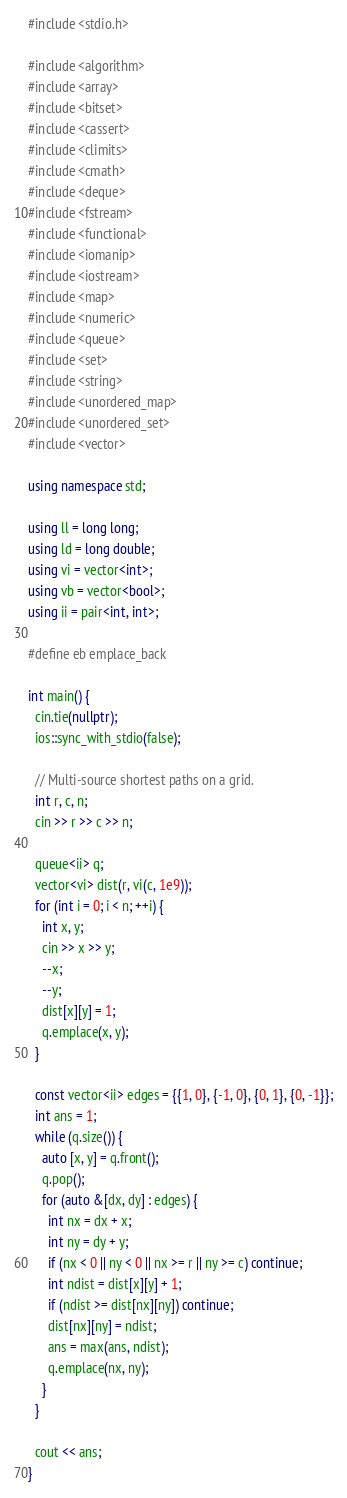<code> <loc_0><loc_0><loc_500><loc_500><_C++_>#include <stdio.h>

#include <algorithm>
#include <array>
#include <bitset>
#include <cassert>
#include <climits>
#include <cmath>
#include <deque>
#include <fstream>
#include <functional>
#include <iomanip>
#include <iostream>
#include <map>
#include <numeric>
#include <queue>
#include <set>
#include <string>
#include <unordered_map>
#include <unordered_set>
#include <vector>

using namespace std;

using ll = long long;
using ld = long double;
using vi = vector<int>;
using vb = vector<bool>;
using ii = pair<int, int>;

#define eb emplace_back

int main() {
  cin.tie(nullptr);
  ios::sync_with_stdio(false);

  // Multi-source shortest paths on a grid.
  int r, c, n;
  cin >> r >> c >> n;

  queue<ii> q;
  vector<vi> dist(r, vi(c, 1e9));
  for (int i = 0; i < n; ++i) {
    int x, y;
    cin >> x >> y;
    --x;
    --y;
    dist[x][y] = 1;
    q.emplace(x, y);
  }

  const vector<ii> edges = {{1, 0}, {-1, 0}, {0, 1}, {0, -1}};
  int ans = 1;
  while (q.size()) {
    auto [x, y] = q.front();
    q.pop();
    for (auto &[dx, dy] : edges) {
      int nx = dx + x;
      int ny = dy + y;
      if (nx < 0 || ny < 0 || nx >= r || ny >= c) continue;
      int ndist = dist[x][y] + 1;
      if (ndist >= dist[nx][ny]) continue;
      dist[nx][ny] = ndist;
      ans = max(ans, ndist);
      q.emplace(nx, ny);
    }
  }

  cout << ans;
}
</code> 